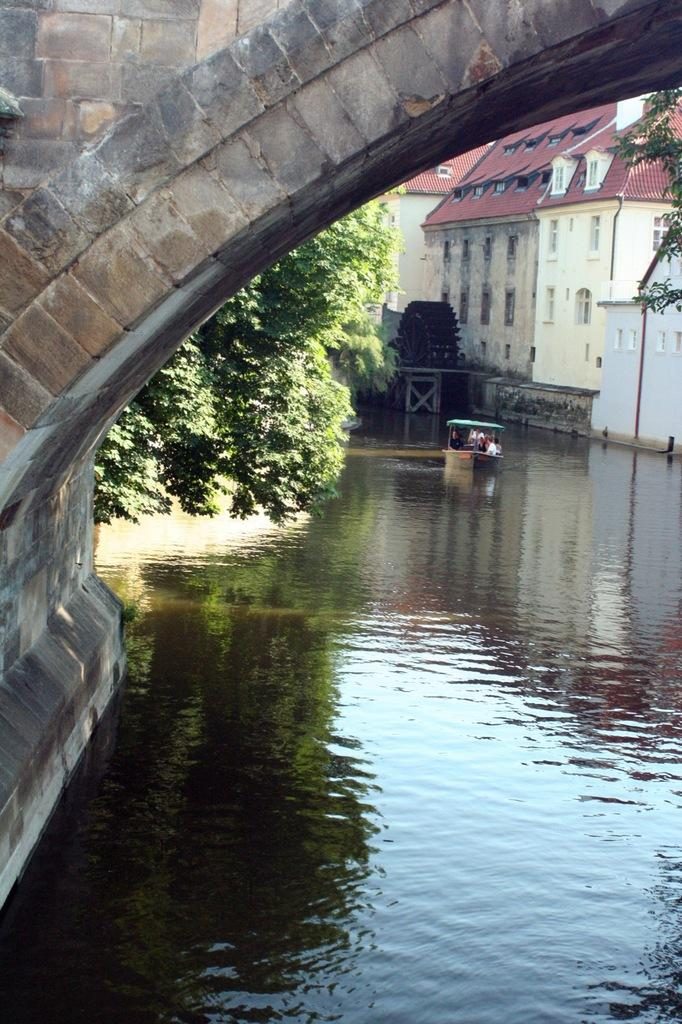What type of structure can be seen in the picture? There is a bridge in the picture. What natural feature is present in the picture? There is a lake in the picture. What type of vegetation is visible in the picture? There are trees in the picture. Are there any man-made structures in the picture? Yes, there is a building in the picture. How many geese are swimming in the lake in the picture? There are no geese present in the picture; it only features a bridge, a lake, trees, and a building. What type of support is the bridge using to stay above the lake? The image does not provide information about the type of support the bridge is using; it only shows the bridge's appearance. 